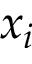Convert formula to latex. <formula><loc_0><loc_0><loc_500><loc_500>x _ { i }</formula> 